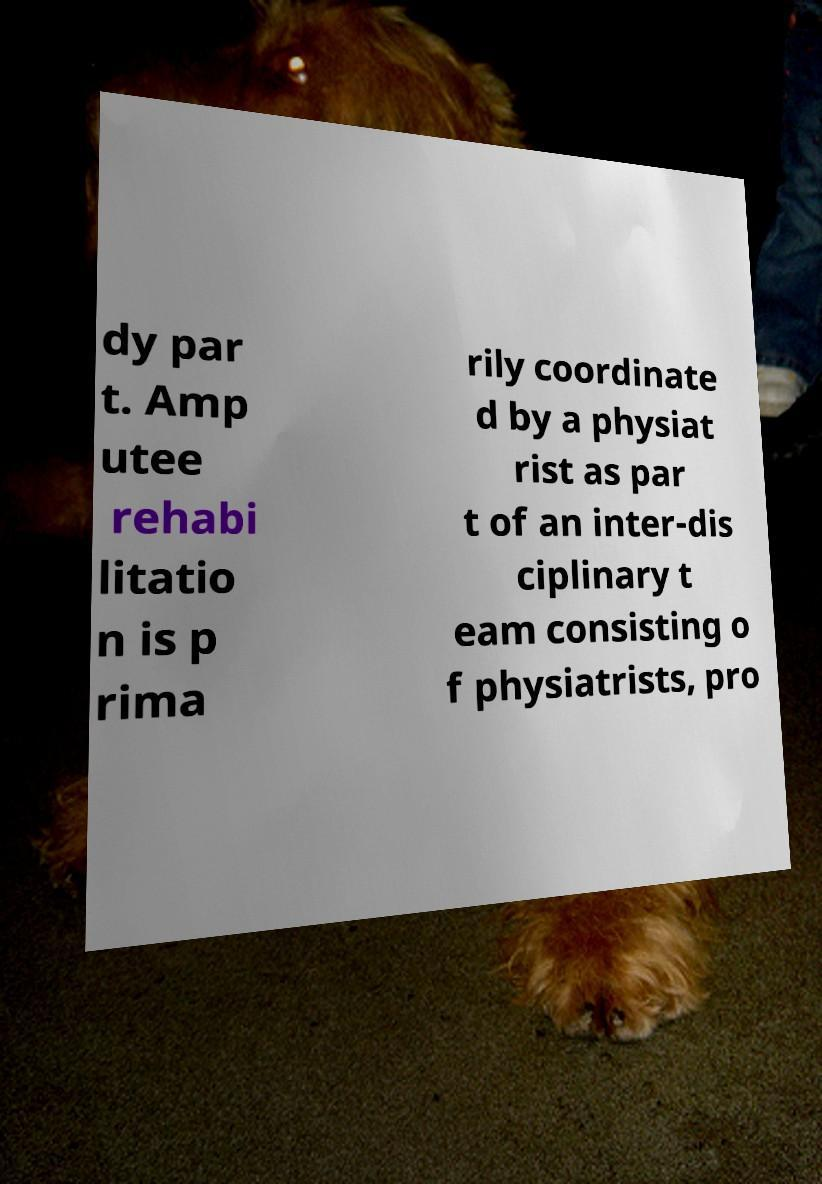Could you extract and type out the text from this image? dy par t. Amp utee rehabi litatio n is p rima rily coordinate d by a physiat rist as par t of an inter-dis ciplinary t eam consisting o f physiatrists, pro 